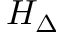<formula> <loc_0><loc_0><loc_500><loc_500>H _ { \Delta }</formula> 